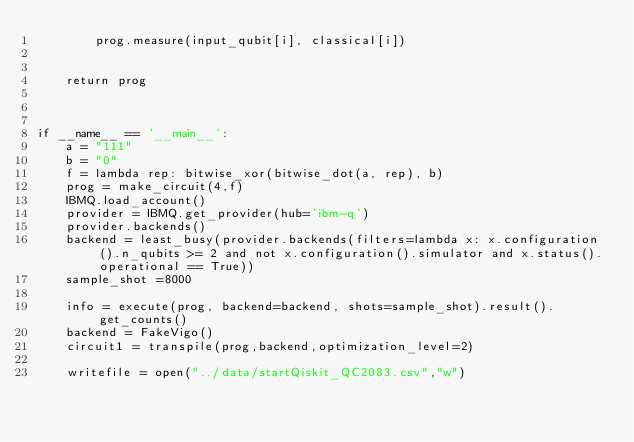<code> <loc_0><loc_0><loc_500><loc_500><_Python_>        prog.measure(input_qubit[i], classical[i])


    return prog



if __name__ == '__main__':
    a = "111"
    b = "0"
    f = lambda rep: bitwise_xor(bitwise_dot(a, rep), b)
    prog = make_circuit(4,f)
    IBMQ.load_account() 
    provider = IBMQ.get_provider(hub='ibm-q') 
    provider.backends()
    backend = least_busy(provider.backends(filters=lambda x: x.configuration().n_qubits >= 2 and not x.configuration().simulator and x.status().operational == True))
    sample_shot =8000

    info = execute(prog, backend=backend, shots=sample_shot).result().get_counts()
    backend = FakeVigo()
    circuit1 = transpile(prog,backend,optimization_level=2)

    writefile = open("../data/startQiskit_QC2083.csv","w")</code> 